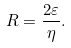Convert formula to latex. <formula><loc_0><loc_0><loc_500><loc_500>R = \frac { 2 \varepsilon } { \eta } .</formula> 